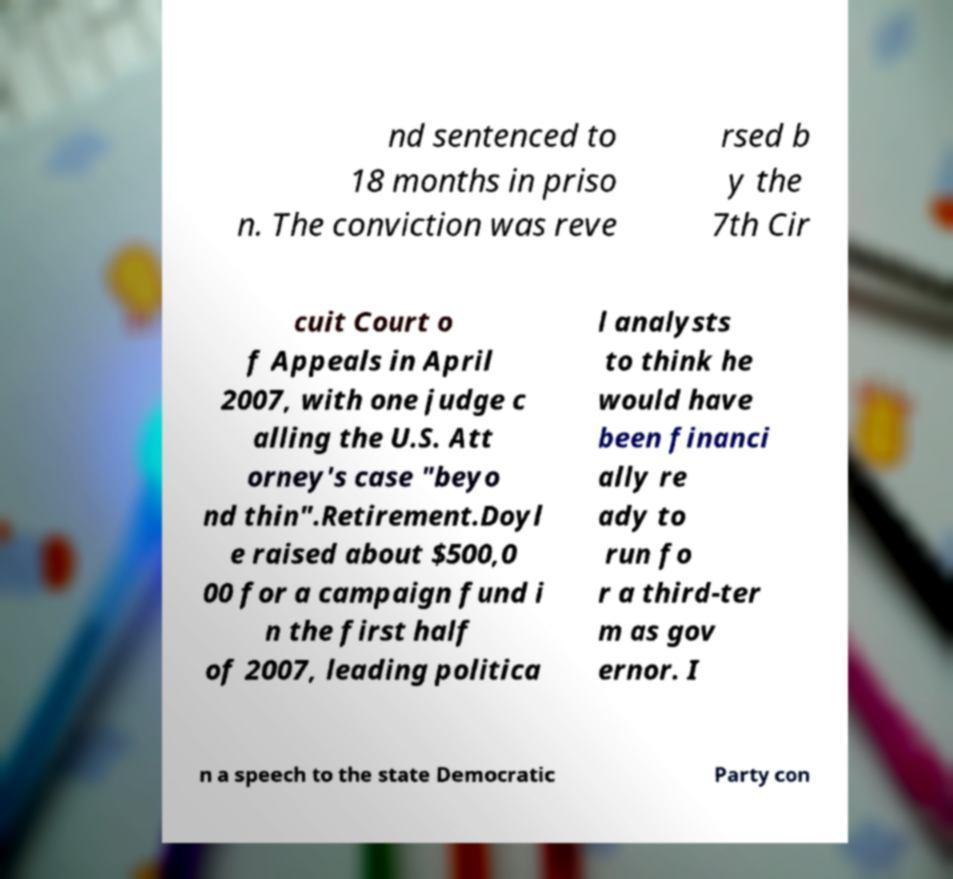Can you read and provide the text displayed in the image?This photo seems to have some interesting text. Can you extract and type it out for me? nd sentenced to 18 months in priso n. The conviction was reve rsed b y the 7th Cir cuit Court o f Appeals in April 2007, with one judge c alling the U.S. Att orney's case "beyo nd thin".Retirement.Doyl e raised about $500,0 00 for a campaign fund i n the first half of 2007, leading politica l analysts to think he would have been financi ally re ady to run fo r a third-ter m as gov ernor. I n a speech to the state Democratic Party con 